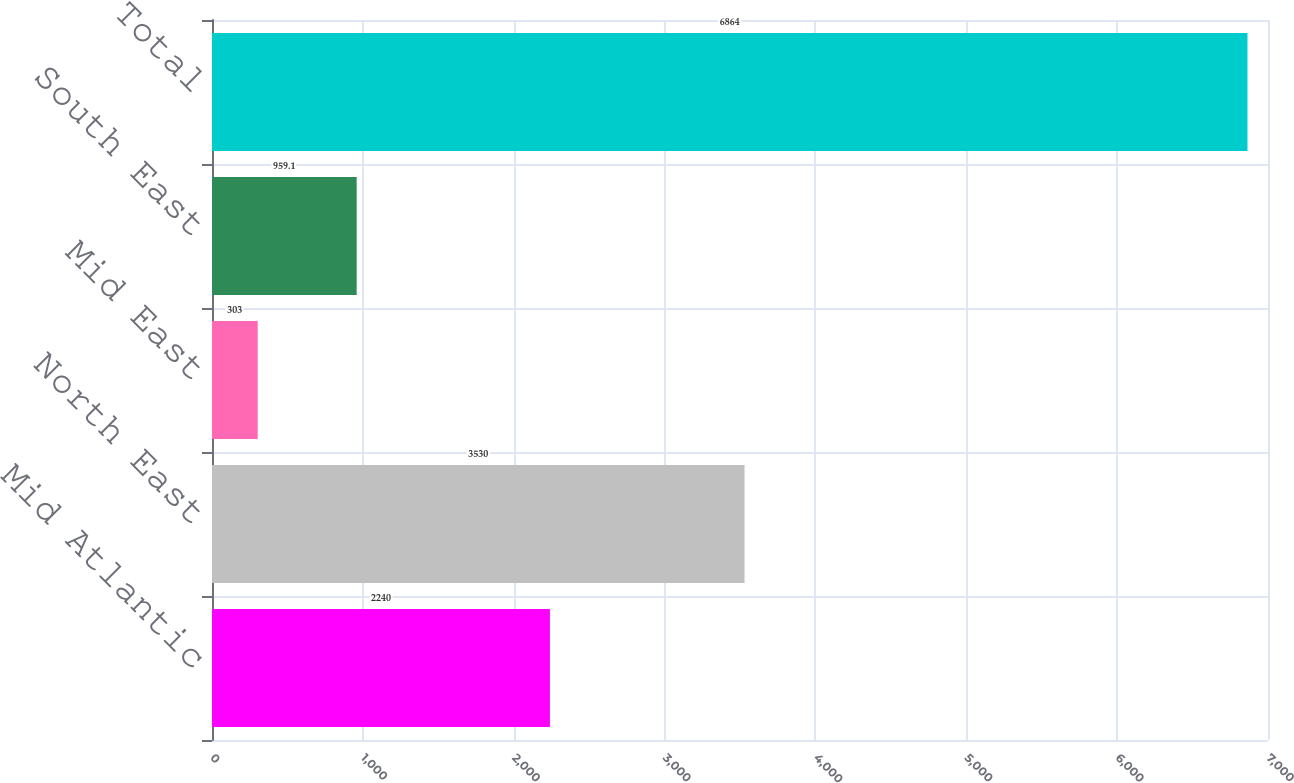<chart> <loc_0><loc_0><loc_500><loc_500><bar_chart><fcel>Mid Atlantic<fcel>North East<fcel>Mid East<fcel>South East<fcel>Total<nl><fcel>2240<fcel>3530<fcel>303<fcel>959.1<fcel>6864<nl></chart> 